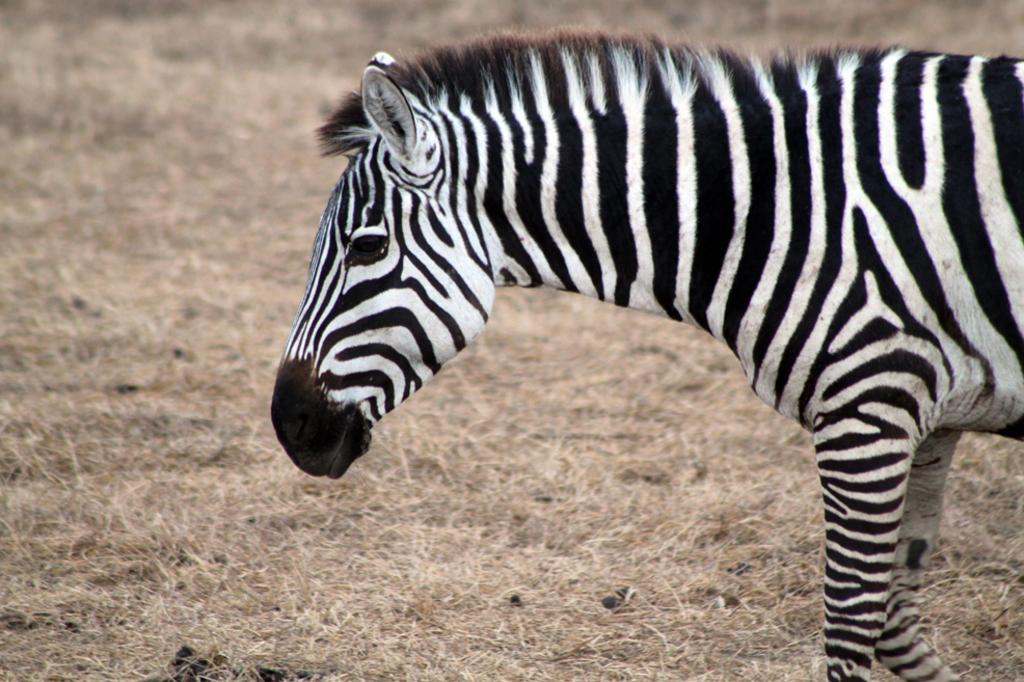What animal is present in the image? There is a zebra in the picture. What type of vegetation can be seen in the image? There is grass in the picture. What is the taste of the alley in the image? There is no alley present in the image, and therefore no taste can be associated with it. 